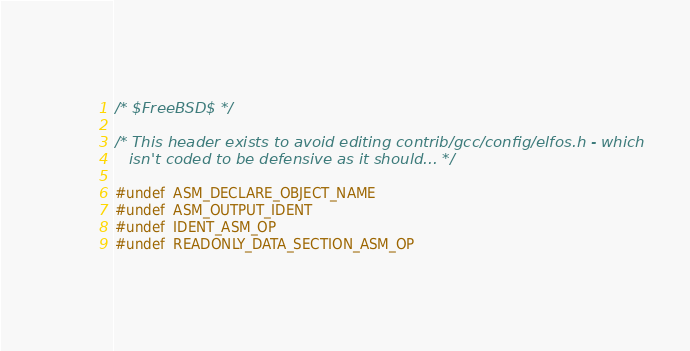Convert code to text. <code><loc_0><loc_0><loc_500><loc_500><_C_>/* $FreeBSD$ */

/* This header exists to avoid editing contrib/gcc/config/elfos.h - which
   isn't coded to be defensive as it should... */

#undef  ASM_DECLARE_OBJECT_NAME
#undef  ASM_OUTPUT_IDENT
#undef  IDENT_ASM_OP
#undef  READONLY_DATA_SECTION_ASM_OP
</code> 